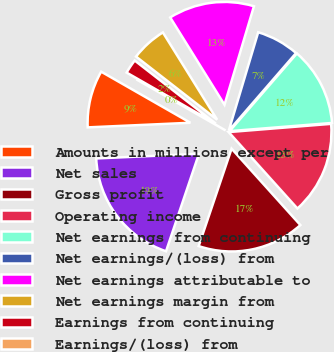Convert chart to OTSL. <chart><loc_0><loc_0><loc_500><loc_500><pie_chart><fcel>Amounts in millions except per<fcel>Net sales<fcel>Gross profit<fcel>Operating income<fcel>Net earnings from continuing<fcel>Net earnings/(loss) from<fcel>Net earnings attributable to<fcel>Net earnings margin from<fcel>Earnings from continuing<fcel>Earnings/(loss) from<nl><fcel>8.99%<fcel>19.1%<fcel>16.85%<fcel>14.61%<fcel>12.36%<fcel>6.74%<fcel>13.48%<fcel>5.62%<fcel>2.25%<fcel>0.0%<nl></chart> 